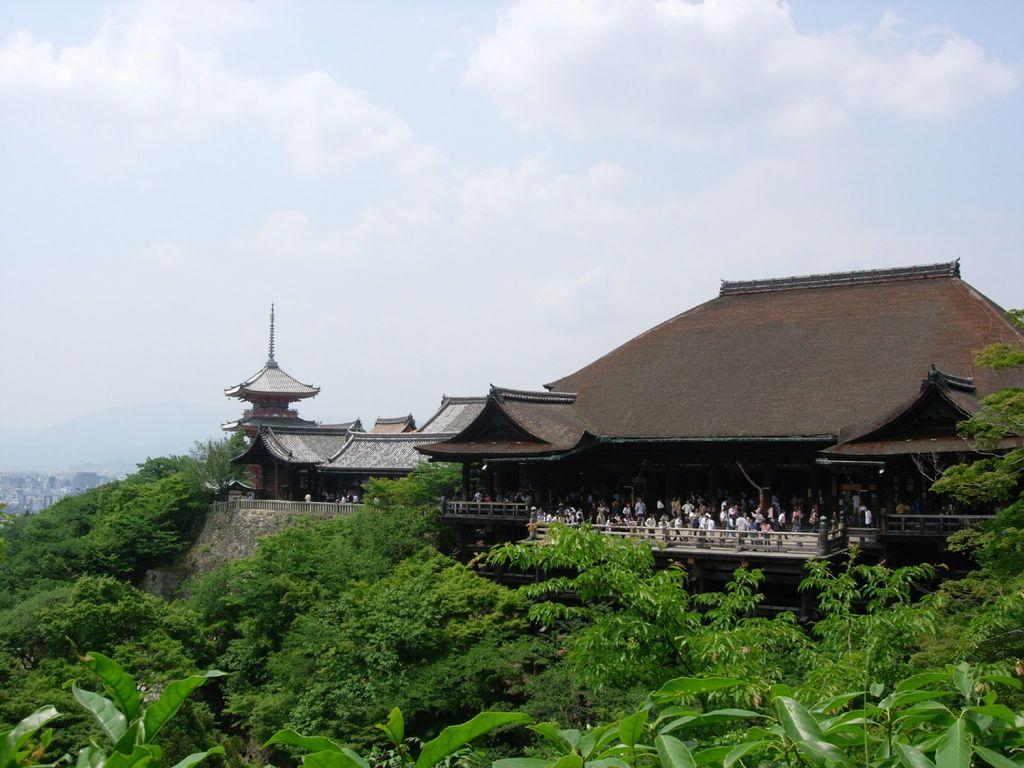What type of structures can be seen in the image? There are houses in the image. Are there any people present in the image? Yes, there are people in the image. What can be seen near the houses? There is a railing in the image. What type of vegetation is visible at the bottom of the image? Trees are visible at the bottom of the image. What is the condition of the sky in the image? The sky is cloudy and visible at the top of the image. How many crows are sitting on the door in the image? There is no door or crow present in the image. What type of clothing are the women wearing in the image? There is no mention of women in the provided facts, so we cannot answer this question. 